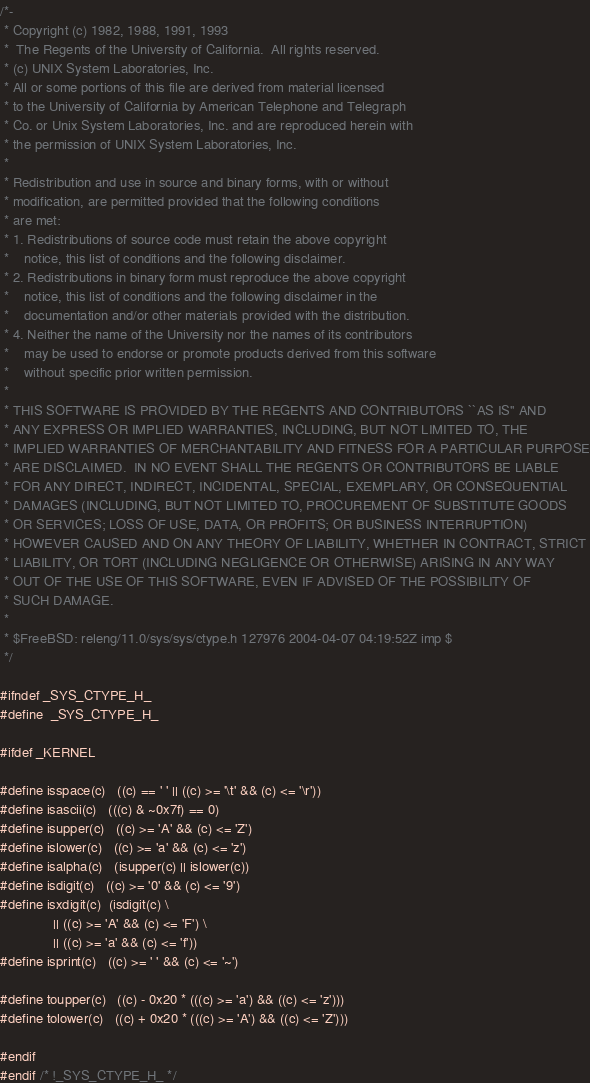<code> <loc_0><loc_0><loc_500><loc_500><_C_>/*-
 * Copyright (c) 1982, 1988, 1991, 1993
 *	The Regents of the University of California.  All rights reserved.
 * (c) UNIX System Laboratories, Inc.
 * All or some portions of this file are derived from material licensed
 * to the University of California by American Telephone and Telegraph
 * Co. or Unix System Laboratories, Inc. and are reproduced herein with
 * the permission of UNIX System Laboratories, Inc.
 *
 * Redistribution and use in source and binary forms, with or without
 * modification, are permitted provided that the following conditions
 * are met:
 * 1. Redistributions of source code must retain the above copyright
 *    notice, this list of conditions and the following disclaimer.
 * 2. Redistributions in binary form must reproduce the above copyright
 *    notice, this list of conditions and the following disclaimer in the
 *    documentation and/or other materials provided with the distribution.
 * 4. Neither the name of the University nor the names of its contributors
 *    may be used to endorse or promote products derived from this software
 *    without specific prior written permission.
 *
 * THIS SOFTWARE IS PROVIDED BY THE REGENTS AND CONTRIBUTORS ``AS IS'' AND
 * ANY EXPRESS OR IMPLIED WARRANTIES, INCLUDING, BUT NOT LIMITED TO, THE
 * IMPLIED WARRANTIES OF MERCHANTABILITY AND FITNESS FOR A PARTICULAR PURPOSE
 * ARE DISCLAIMED.  IN NO EVENT SHALL THE REGENTS OR CONTRIBUTORS BE LIABLE
 * FOR ANY DIRECT, INDIRECT, INCIDENTAL, SPECIAL, EXEMPLARY, OR CONSEQUENTIAL
 * DAMAGES (INCLUDING, BUT NOT LIMITED TO, PROCUREMENT OF SUBSTITUTE GOODS
 * OR SERVICES; LOSS OF USE, DATA, OR PROFITS; OR BUSINESS INTERRUPTION)
 * HOWEVER CAUSED AND ON ANY THEORY OF LIABILITY, WHETHER IN CONTRACT, STRICT
 * LIABILITY, OR TORT (INCLUDING NEGLIGENCE OR OTHERWISE) ARISING IN ANY WAY
 * OUT OF THE USE OF THIS SOFTWARE, EVEN IF ADVISED OF THE POSSIBILITY OF
 * SUCH DAMAGE.
 *
 * $FreeBSD: releng/11.0/sys/sys/ctype.h 127976 2004-04-07 04:19:52Z imp $
 */

#ifndef _SYS_CTYPE_H_
#define	_SYS_CTYPE_H_

#ifdef _KERNEL

#define isspace(c)	((c) == ' ' || ((c) >= '\t' && (c) <= '\r'))
#define isascii(c)	(((c) & ~0x7f) == 0)
#define isupper(c)	((c) >= 'A' && (c) <= 'Z')
#define islower(c)	((c) >= 'a' && (c) <= 'z')
#define isalpha(c)	(isupper(c) || islower(c))
#define isdigit(c)	((c) >= '0' && (c) <= '9')
#define isxdigit(c)	(isdigit(c) \
			  || ((c) >= 'A' && (c) <= 'F') \
			  || ((c) >= 'a' && (c) <= 'f'))
#define isprint(c)	((c) >= ' ' && (c) <= '~')

#define toupper(c)	((c) - 0x20 * (((c) >= 'a') && ((c) <= 'z')))
#define tolower(c)	((c) + 0x20 * (((c) >= 'A') && ((c) <= 'Z')))

#endif
#endif /* !_SYS_CTYPE_H_ */
</code> 